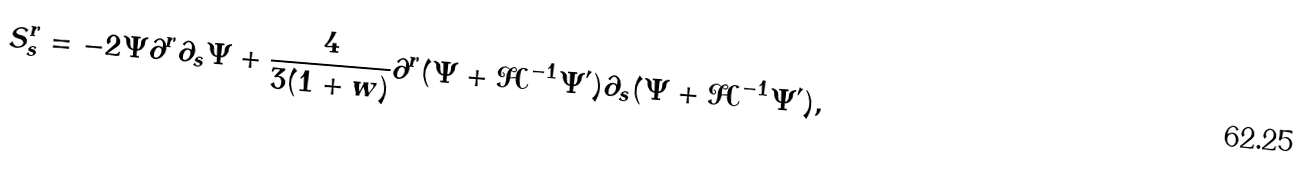<formula> <loc_0><loc_0><loc_500><loc_500>S ^ { r } _ { s } = - 2 \Psi \partial ^ { r } \partial _ { s } \Psi + \frac { 4 } { 3 ( 1 + w ) } \partial ^ { r } ( \Psi + \mathcal { H } ^ { - 1 } \Psi ^ { \prime } ) \partial _ { s } ( \Psi + \mathcal { H } ^ { - 1 } \Psi ^ { \prime } ) ,</formula> 